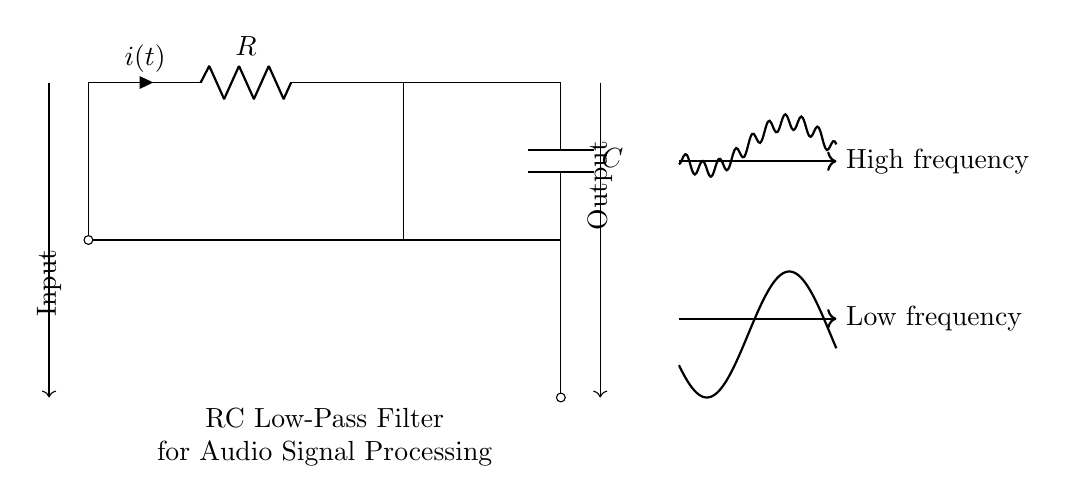What is the input and output in this circuit? The input is labeled at the left side of the circuit diagram, where the current enters the circuit. The output is labeled at the right side, where the processed signal exits.
Answer: Input and Output What components are present in this circuit? The circuit consists of a resistor and a capacitor. The resistor is denoted by R and the capacitor by C in the diagram.
Answer: Resistor and Capacitor What is the function of the RC low-pass filter? The RC low-pass filter allows low-frequency signals to pass through while attenuating high-frequency signals, effectively filtering the audio signal.
Answer: Filtering audio signals What is the current denoted as in the circuit? The current flowing through the circuit is denoted as i(t) next to the resistor, which represents the instantaneous current at time t.
Answer: i(t) What happens to high-frequency signals in this filter? High-frequency signals are significantly attenuated or reduced in amplitude when they pass through an RC low-pass filter, resulting in a softer output signal.
Answer: They are attenuated How does the capacitor affect the circuit's response to low and high frequencies? The capacitor stores and releases energy, which allows low-frequency signals to pass more easily while blocking high-frequency signals due to its increasing reactance with frequency.
Answer: It allows low frequencies and blocks high frequencies 